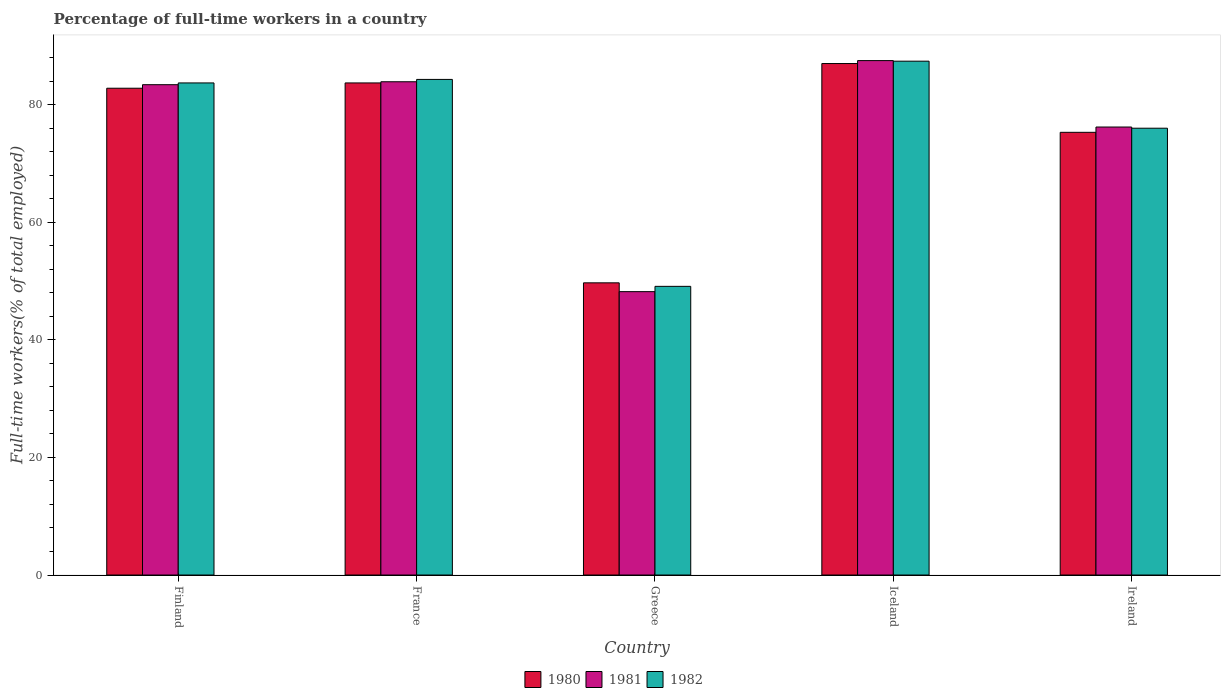How many different coloured bars are there?
Provide a short and direct response. 3. What is the label of the 3rd group of bars from the left?
Offer a terse response. Greece. What is the percentage of full-time workers in 1982 in Finland?
Your answer should be very brief. 83.7. Across all countries, what is the maximum percentage of full-time workers in 1982?
Provide a short and direct response. 87.4. Across all countries, what is the minimum percentage of full-time workers in 1982?
Provide a succinct answer. 49.1. In which country was the percentage of full-time workers in 1980 minimum?
Offer a very short reply. Greece. What is the total percentage of full-time workers in 1982 in the graph?
Your answer should be very brief. 380.5. What is the difference between the percentage of full-time workers in 1981 in Finland and that in France?
Provide a succinct answer. -0.5. What is the difference between the percentage of full-time workers in 1981 in France and the percentage of full-time workers in 1980 in Finland?
Your answer should be very brief. 1.1. What is the average percentage of full-time workers in 1981 per country?
Your answer should be very brief. 75.84. What is the difference between the percentage of full-time workers of/in 1980 and percentage of full-time workers of/in 1982 in Greece?
Offer a very short reply. 0.6. In how many countries, is the percentage of full-time workers in 1980 greater than 48 %?
Keep it short and to the point. 5. What is the ratio of the percentage of full-time workers in 1981 in Greece to that in Iceland?
Your response must be concise. 0.55. Is the percentage of full-time workers in 1982 in France less than that in Ireland?
Give a very brief answer. No. What is the difference between the highest and the lowest percentage of full-time workers in 1982?
Keep it short and to the point. 38.3. Is the sum of the percentage of full-time workers in 1980 in France and Greece greater than the maximum percentage of full-time workers in 1982 across all countries?
Your response must be concise. Yes. What does the 3rd bar from the left in France represents?
Keep it short and to the point. 1982. What does the 1st bar from the right in Ireland represents?
Your answer should be compact. 1982. Is it the case that in every country, the sum of the percentage of full-time workers in 1981 and percentage of full-time workers in 1982 is greater than the percentage of full-time workers in 1980?
Offer a very short reply. Yes. How many countries are there in the graph?
Keep it short and to the point. 5. What is the difference between two consecutive major ticks on the Y-axis?
Provide a short and direct response. 20. Does the graph contain any zero values?
Keep it short and to the point. No. How are the legend labels stacked?
Your answer should be very brief. Horizontal. What is the title of the graph?
Your answer should be very brief. Percentage of full-time workers in a country. What is the label or title of the X-axis?
Offer a very short reply. Country. What is the label or title of the Y-axis?
Provide a succinct answer. Full-time workers(% of total employed). What is the Full-time workers(% of total employed) of 1980 in Finland?
Offer a very short reply. 82.8. What is the Full-time workers(% of total employed) of 1981 in Finland?
Keep it short and to the point. 83.4. What is the Full-time workers(% of total employed) of 1982 in Finland?
Make the answer very short. 83.7. What is the Full-time workers(% of total employed) in 1980 in France?
Make the answer very short. 83.7. What is the Full-time workers(% of total employed) in 1981 in France?
Your answer should be very brief. 83.9. What is the Full-time workers(% of total employed) of 1982 in France?
Make the answer very short. 84.3. What is the Full-time workers(% of total employed) in 1980 in Greece?
Your answer should be very brief. 49.7. What is the Full-time workers(% of total employed) of 1981 in Greece?
Your answer should be very brief. 48.2. What is the Full-time workers(% of total employed) in 1982 in Greece?
Your answer should be compact. 49.1. What is the Full-time workers(% of total employed) of 1981 in Iceland?
Give a very brief answer. 87.5. What is the Full-time workers(% of total employed) of 1982 in Iceland?
Your answer should be compact. 87.4. What is the Full-time workers(% of total employed) of 1980 in Ireland?
Make the answer very short. 75.3. What is the Full-time workers(% of total employed) of 1981 in Ireland?
Offer a terse response. 76.2. What is the Full-time workers(% of total employed) of 1982 in Ireland?
Your response must be concise. 76. Across all countries, what is the maximum Full-time workers(% of total employed) in 1980?
Give a very brief answer. 87. Across all countries, what is the maximum Full-time workers(% of total employed) in 1981?
Make the answer very short. 87.5. Across all countries, what is the maximum Full-time workers(% of total employed) in 1982?
Make the answer very short. 87.4. Across all countries, what is the minimum Full-time workers(% of total employed) in 1980?
Your response must be concise. 49.7. Across all countries, what is the minimum Full-time workers(% of total employed) of 1981?
Ensure brevity in your answer.  48.2. Across all countries, what is the minimum Full-time workers(% of total employed) in 1982?
Provide a short and direct response. 49.1. What is the total Full-time workers(% of total employed) of 1980 in the graph?
Your answer should be very brief. 378.5. What is the total Full-time workers(% of total employed) of 1981 in the graph?
Give a very brief answer. 379.2. What is the total Full-time workers(% of total employed) in 1982 in the graph?
Offer a very short reply. 380.5. What is the difference between the Full-time workers(% of total employed) of 1981 in Finland and that in France?
Keep it short and to the point. -0.5. What is the difference between the Full-time workers(% of total employed) of 1980 in Finland and that in Greece?
Make the answer very short. 33.1. What is the difference between the Full-time workers(% of total employed) in 1981 in Finland and that in Greece?
Provide a succinct answer. 35.2. What is the difference between the Full-time workers(% of total employed) of 1982 in Finland and that in Greece?
Your response must be concise. 34.6. What is the difference between the Full-time workers(% of total employed) of 1981 in Finland and that in Iceland?
Offer a very short reply. -4.1. What is the difference between the Full-time workers(% of total employed) in 1982 in Finland and that in Iceland?
Provide a short and direct response. -3.7. What is the difference between the Full-time workers(% of total employed) of 1980 in Finland and that in Ireland?
Your answer should be very brief. 7.5. What is the difference between the Full-time workers(% of total employed) in 1982 in Finland and that in Ireland?
Offer a terse response. 7.7. What is the difference between the Full-time workers(% of total employed) in 1981 in France and that in Greece?
Your answer should be very brief. 35.7. What is the difference between the Full-time workers(% of total employed) in 1982 in France and that in Greece?
Your answer should be very brief. 35.2. What is the difference between the Full-time workers(% of total employed) in 1981 in France and that in Iceland?
Give a very brief answer. -3.6. What is the difference between the Full-time workers(% of total employed) in 1980 in France and that in Ireland?
Your answer should be compact. 8.4. What is the difference between the Full-time workers(% of total employed) in 1981 in France and that in Ireland?
Make the answer very short. 7.7. What is the difference between the Full-time workers(% of total employed) in 1982 in France and that in Ireland?
Your answer should be very brief. 8.3. What is the difference between the Full-time workers(% of total employed) in 1980 in Greece and that in Iceland?
Your answer should be very brief. -37.3. What is the difference between the Full-time workers(% of total employed) of 1981 in Greece and that in Iceland?
Provide a succinct answer. -39.3. What is the difference between the Full-time workers(% of total employed) of 1982 in Greece and that in Iceland?
Offer a terse response. -38.3. What is the difference between the Full-time workers(% of total employed) of 1980 in Greece and that in Ireland?
Offer a very short reply. -25.6. What is the difference between the Full-time workers(% of total employed) of 1981 in Greece and that in Ireland?
Offer a terse response. -28. What is the difference between the Full-time workers(% of total employed) in 1982 in Greece and that in Ireland?
Give a very brief answer. -26.9. What is the difference between the Full-time workers(% of total employed) of 1982 in Iceland and that in Ireland?
Ensure brevity in your answer.  11.4. What is the difference between the Full-time workers(% of total employed) in 1980 in Finland and the Full-time workers(% of total employed) in 1981 in Greece?
Provide a succinct answer. 34.6. What is the difference between the Full-time workers(% of total employed) of 1980 in Finland and the Full-time workers(% of total employed) of 1982 in Greece?
Provide a succinct answer. 33.7. What is the difference between the Full-time workers(% of total employed) in 1981 in Finland and the Full-time workers(% of total employed) in 1982 in Greece?
Your response must be concise. 34.3. What is the difference between the Full-time workers(% of total employed) in 1981 in Finland and the Full-time workers(% of total employed) in 1982 in Iceland?
Give a very brief answer. -4. What is the difference between the Full-time workers(% of total employed) in 1980 in Finland and the Full-time workers(% of total employed) in 1981 in Ireland?
Give a very brief answer. 6.6. What is the difference between the Full-time workers(% of total employed) in 1980 in France and the Full-time workers(% of total employed) in 1981 in Greece?
Provide a short and direct response. 35.5. What is the difference between the Full-time workers(% of total employed) of 1980 in France and the Full-time workers(% of total employed) of 1982 in Greece?
Give a very brief answer. 34.6. What is the difference between the Full-time workers(% of total employed) of 1981 in France and the Full-time workers(% of total employed) of 1982 in Greece?
Offer a very short reply. 34.8. What is the difference between the Full-time workers(% of total employed) in 1980 in France and the Full-time workers(% of total employed) in 1981 in Iceland?
Offer a very short reply. -3.8. What is the difference between the Full-time workers(% of total employed) of 1981 in France and the Full-time workers(% of total employed) of 1982 in Iceland?
Keep it short and to the point. -3.5. What is the difference between the Full-time workers(% of total employed) of 1980 in France and the Full-time workers(% of total employed) of 1981 in Ireland?
Provide a succinct answer. 7.5. What is the difference between the Full-time workers(% of total employed) of 1981 in France and the Full-time workers(% of total employed) of 1982 in Ireland?
Your answer should be very brief. 7.9. What is the difference between the Full-time workers(% of total employed) in 1980 in Greece and the Full-time workers(% of total employed) in 1981 in Iceland?
Your answer should be compact. -37.8. What is the difference between the Full-time workers(% of total employed) in 1980 in Greece and the Full-time workers(% of total employed) in 1982 in Iceland?
Your answer should be compact. -37.7. What is the difference between the Full-time workers(% of total employed) of 1981 in Greece and the Full-time workers(% of total employed) of 1982 in Iceland?
Offer a very short reply. -39.2. What is the difference between the Full-time workers(% of total employed) of 1980 in Greece and the Full-time workers(% of total employed) of 1981 in Ireland?
Make the answer very short. -26.5. What is the difference between the Full-time workers(% of total employed) of 1980 in Greece and the Full-time workers(% of total employed) of 1982 in Ireland?
Offer a terse response. -26.3. What is the difference between the Full-time workers(% of total employed) in 1981 in Greece and the Full-time workers(% of total employed) in 1982 in Ireland?
Offer a terse response. -27.8. What is the difference between the Full-time workers(% of total employed) in 1980 in Iceland and the Full-time workers(% of total employed) in 1981 in Ireland?
Your response must be concise. 10.8. What is the average Full-time workers(% of total employed) in 1980 per country?
Your answer should be compact. 75.7. What is the average Full-time workers(% of total employed) in 1981 per country?
Your answer should be very brief. 75.84. What is the average Full-time workers(% of total employed) of 1982 per country?
Your answer should be compact. 76.1. What is the difference between the Full-time workers(% of total employed) of 1980 and Full-time workers(% of total employed) of 1981 in Finland?
Offer a terse response. -0.6. What is the difference between the Full-time workers(% of total employed) in 1980 and Full-time workers(% of total employed) in 1982 in Finland?
Offer a very short reply. -0.9. What is the difference between the Full-time workers(% of total employed) of 1981 and Full-time workers(% of total employed) of 1982 in Finland?
Ensure brevity in your answer.  -0.3. What is the difference between the Full-time workers(% of total employed) of 1980 and Full-time workers(% of total employed) of 1981 in France?
Ensure brevity in your answer.  -0.2. What is the difference between the Full-time workers(% of total employed) of 1980 and Full-time workers(% of total employed) of 1982 in France?
Offer a very short reply. -0.6. What is the difference between the Full-time workers(% of total employed) in 1981 and Full-time workers(% of total employed) in 1982 in France?
Offer a very short reply. -0.4. What is the difference between the Full-time workers(% of total employed) in 1980 and Full-time workers(% of total employed) in 1982 in Greece?
Offer a terse response. 0.6. What is the difference between the Full-time workers(% of total employed) of 1981 and Full-time workers(% of total employed) of 1982 in Greece?
Offer a very short reply. -0.9. What is the difference between the Full-time workers(% of total employed) in 1980 and Full-time workers(% of total employed) in 1981 in Iceland?
Give a very brief answer. -0.5. What is the difference between the Full-time workers(% of total employed) of 1980 and Full-time workers(% of total employed) of 1981 in Ireland?
Give a very brief answer. -0.9. What is the difference between the Full-time workers(% of total employed) of 1980 and Full-time workers(% of total employed) of 1982 in Ireland?
Ensure brevity in your answer.  -0.7. What is the ratio of the Full-time workers(% of total employed) of 1982 in Finland to that in France?
Keep it short and to the point. 0.99. What is the ratio of the Full-time workers(% of total employed) of 1980 in Finland to that in Greece?
Your response must be concise. 1.67. What is the ratio of the Full-time workers(% of total employed) of 1981 in Finland to that in Greece?
Offer a terse response. 1.73. What is the ratio of the Full-time workers(% of total employed) in 1982 in Finland to that in Greece?
Provide a succinct answer. 1.7. What is the ratio of the Full-time workers(% of total employed) in 1980 in Finland to that in Iceland?
Keep it short and to the point. 0.95. What is the ratio of the Full-time workers(% of total employed) in 1981 in Finland to that in Iceland?
Give a very brief answer. 0.95. What is the ratio of the Full-time workers(% of total employed) in 1982 in Finland to that in Iceland?
Provide a succinct answer. 0.96. What is the ratio of the Full-time workers(% of total employed) in 1980 in Finland to that in Ireland?
Give a very brief answer. 1.1. What is the ratio of the Full-time workers(% of total employed) of 1981 in Finland to that in Ireland?
Make the answer very short. 1.09. What is the ratio of the Full-time workers(% of total employed) in 1982 in Finland to that in Ireland?
Your answer should be compact. 1.1. What is the ratio of the Full-time workers(% of total employed) in 1980 in France to that in Greece?
Offer a very short reply. 1.68. What is the ratio of the Full-time workers(% of total employed) of 1981 in France to that in Greece?
Offer a terse response. 1.74. What is the ratio of the Full-time workers(% of total employed) in 1982 in France to that in Greece?
Your response must be concise. 1.72. What is the ratio of the Full-time workers(% of total employed) of 1980 in France to that in Iceland?
Make the answer very short. 0.96. What is the ratio of the Full-time workers(% of total employed) in 1981 in France to that in Iceland?
Offer a very short reply. 0.96. What is the ratio of the Full-time workers(% of total employed) in 1982 in France to that in Iceland?
Ensure brevity in your answer.  0.96. What is the ratio of the Full-time workers(% of total employed) of 1980 in France to that in Ireland?
Your answer should be very brief. 1.11. What is the ratio of the Full-time workers(% of total employed) of 1981 in France to that in Ireland?
Your answer should be very brief. 1.1. What is the ratio of the Full-time workers(% of total employed) of 1982 in France to that in Ireland?
Provide a short and direct response. 1.11. What is the ratio of the Full-time workers(% of total employed) in 1980 in Greece to that in Iceland?
Make the answer very short. 0.57. What is the ratio of the Full-time workers(% of total employed) of 1981 in Greece to that in Iceland?
Keep it short and to the point. 0.55. What is the ratio of the Full-time workers(% of total employed) in 1982 in Greece to that in Iceland?
Offer a terse response. 0.56. What is the ratio of the Full-time workers(% of total employed) in 1980 in Greece to that in Ireland?
Offer a very short reply. 0.66. What is the ratio of the Full-time workers(% of total employed) of 1981 in Greece to that in Ireland?
Keep it short and to the point. 0.63. What is the ratio of the Full-time workers(% of total employed) in 1982 in Greece to that in Ireland?
Offer a very short reply. 0.65. What is the ratio of the Full-time workers(% of total employed) of 1980 in Iceland to that in Ireland?
Make the answer very short. 1.16. What is the ratio of the Full-time workers(% of total employed) in 1981 in Iceland to that in Ireland?
Your answer should be very brief. 1.15. What is the ratio of the Full-time workers(% of total employed) in 1982 in Iceland to that in Ireland?
Your response must be concise. 1.15. What is the difference between the highest and the second highest Full-time workers(% of total employed) in 1982?
Your response must be concise. 3.1. What is the difference between the highest and the lowest Full-time workers(% of total employed) of 1980?
Offer a terse response. 37.3. What is the difference between the highest and the lowest Full-time workers(% of total employed) in 1981?
Offer a terse response. 39.3. What is the difference between the highest and the lowest Full-time workers(% of total employed) in 1982?
Ensure brevity in your answer.  38.3. 